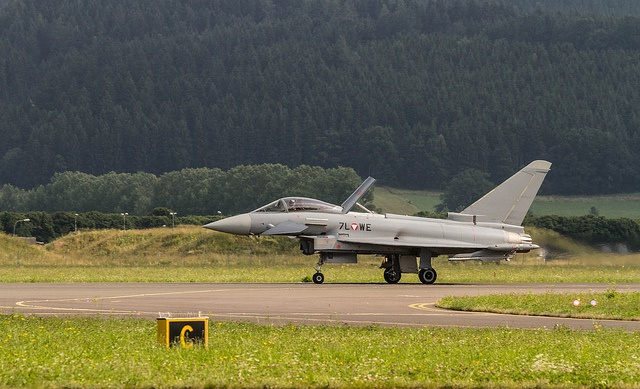Describe the objects in this image and their specific colors. I can see a airplane in gray, darkgray, black, and lightgray tones in this image. 